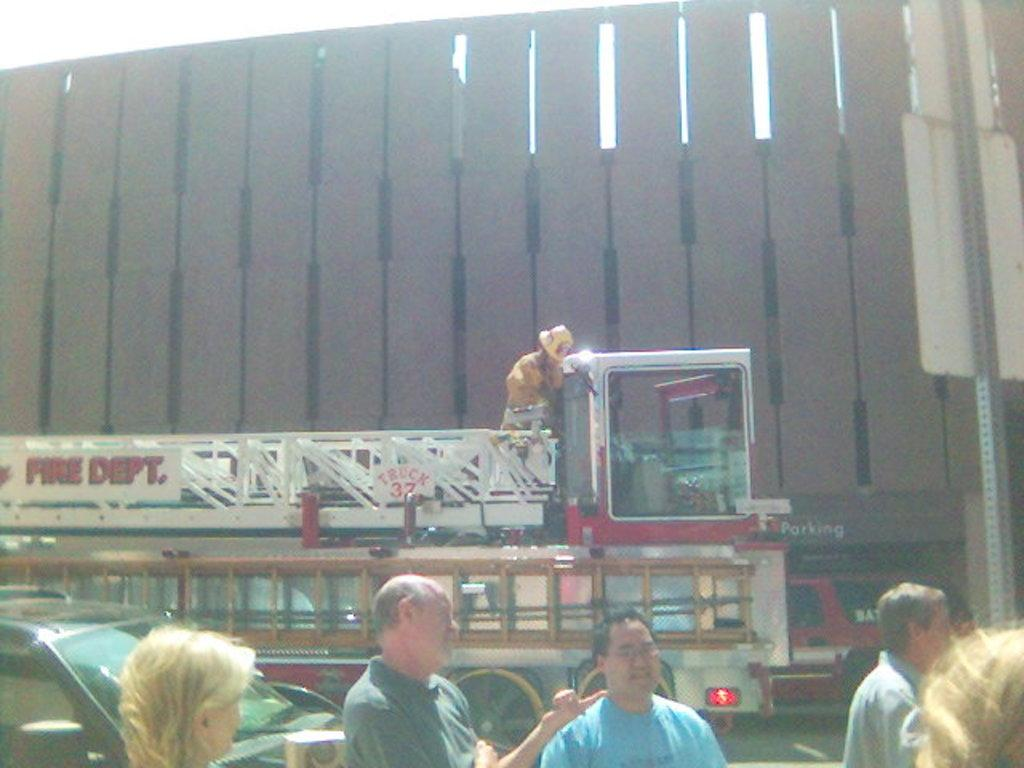How many people are in the image? There is a group of people in the image. What types of vehicles are present in the image? There is a car and a goods vehicle in the image. Where are the vehicles located in the image? The vehicles are on the road in the image. What can be seen in the background of the image? There is a brown-colored building in the image. What book is the expert holding in anger in the image? There is no expert, anger, or book present in the image. 